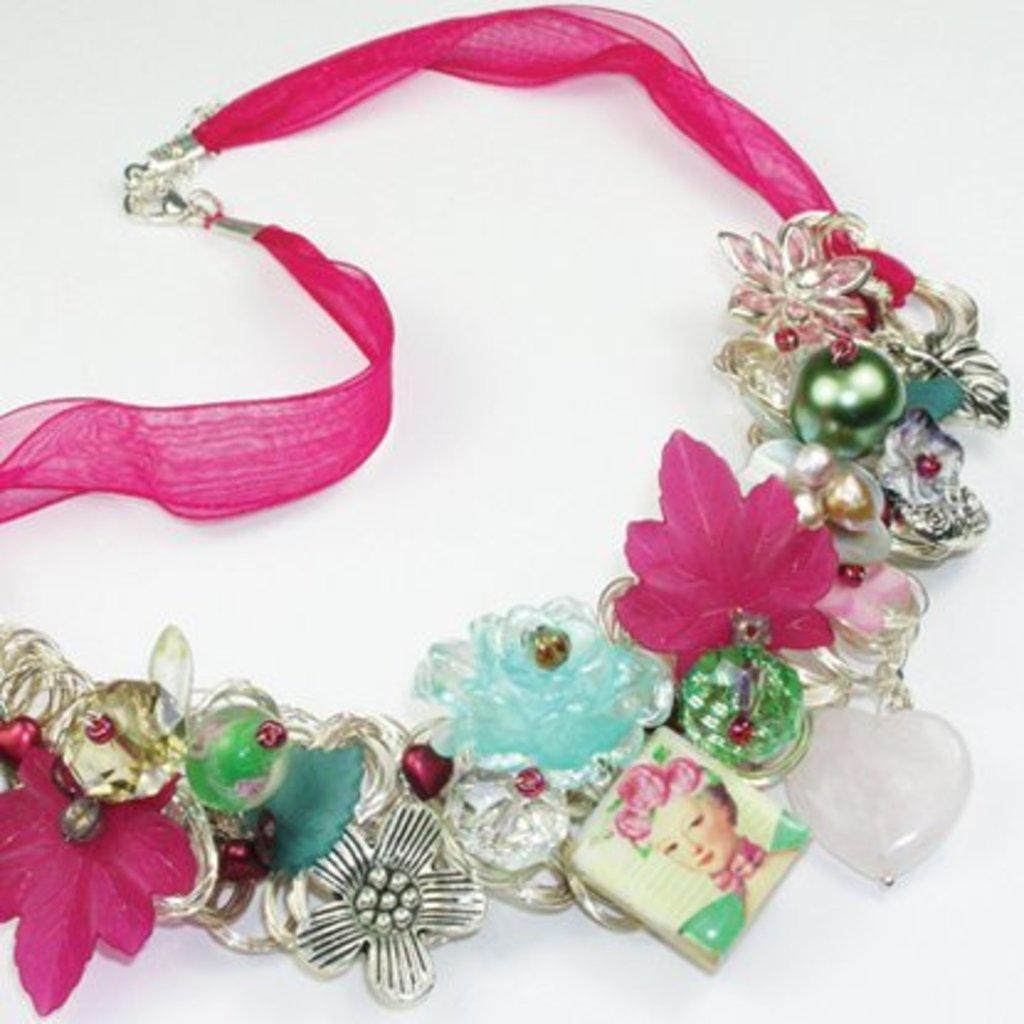How would you summarize this image in a sentence or two? In this image I can see a necklace which is made up of a pink color ribbon. This is placed on a white surface. 